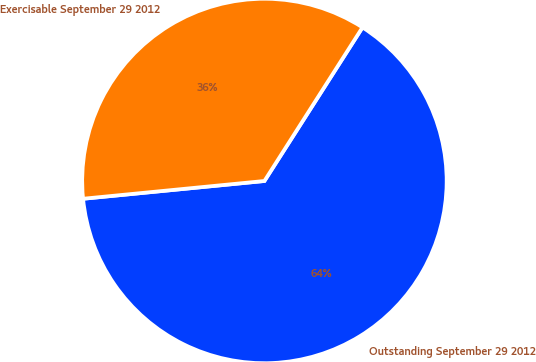<chart> <loc_0><loc_0><loc_500><loc_500><pie_chart><fcel>Outstanding September 29 2012<fcel>Exercisable September 29 2012<nl><fcel>64.4%<fcel>35.6%<nl></chart> 